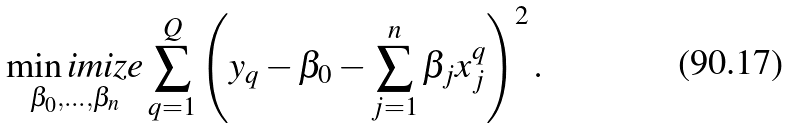Convert formula to latex. <formula><loc_0><loc_0><loc_500><loc_500>\underset { \beta _ { 0 } , \dots , \beta _ { n } } { \min i m i z e } \sum _ { q = 1 } ^ { Q } \left ( y _ { q } - \beta _ { 0 } - \sum _ { j = 1 } ^ { n } \beta _ { j } x ^ { q } _ { j } \right ) ^ { 2 } .</formula> 